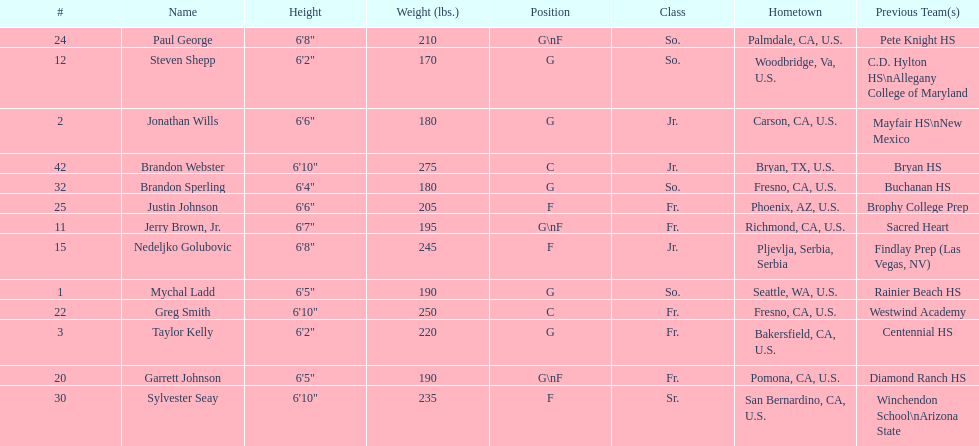Taylor kelly is shorter than 6' 3", which other player is also shorter than 6' 3"? Steven Shepp. 